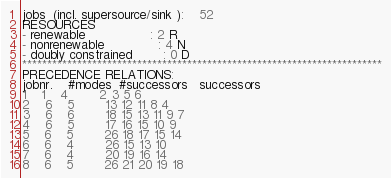Convert code to text. <code><loc_0><loc_0><loc_500><loc_500><_ObjectiveC_>jobs  (incl. supersource/sink ):	52
RESOURCES
- renewable                 : 2 R
- nonrenewable              : 4 N
- doubly constrained        : 0 D
************************************************************************
PRECEDENCE RELATIONS:
jobnr.    #modes  #successors   successors
1	1	4		2 3 5 6 
2	6	5		13 12 11 8 4 
3	6	6		18 15 13 11 9 7 
4	6	5		17 16 15 10 9 
5	6	5		26 18 17 15 14 
6	6	4		26 15 13 10 
7	6	4		20 19 16 14 
8	6	5		26 21 20 19 18 </code> 